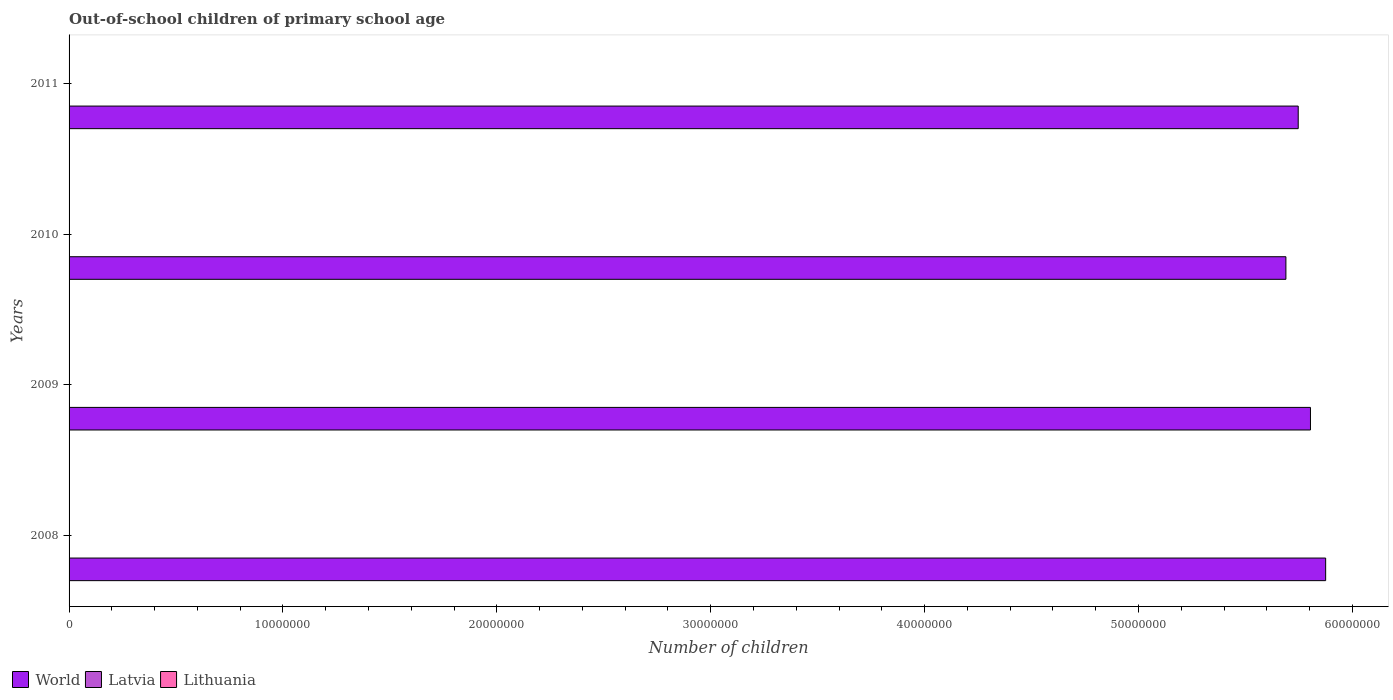Are the number of bars on each tick of the Y-axis equal?
Make the answer very short. Yes. What is the label of the 2nd group of bars from the top?
Your answer should be very brief. 2010. What is the number of out-of-school children in Latvia in 2010?
Give a very brief answer. 2007. Across all years, what is the maximum number of out-of-school children in World?
Keep it short and to the point. 5.88e+07. Across all years, what is the minimum number of out-of-school children in Latvia?
Ensure brevity in your answer.  1985. In which year was the number of out-of-school children in World maximum?
Make the answer very short. 2008. In which year was the number of out-of-school children in World minimum?
Your answer should be compact. 2010. What is the total number of out-of-school children in Lithuania in the graph?
Provide a succinct answer. 6010. What is the difference between the number of out-of-school children in World in 2009 and that in 2010?
Make the answer very short. 1.15e+06. What is the difference between the number of out-of-school children in Lithuania in 2010 and the number of out-of-school children in Latvia in 2009?
Your response must be concise. -682. What is the average number of out-of-school children in World per year?
Provide a short and direct response. 5.78e+07. In the year 2011, what is the difference between the number of out-of-school children in Latvia and number of out-of-school children in Lithuania?
Give a very brief answer. 604. In how many years, is the number of out-of-school children in World greater than 16000000 ?
Keep it short and to the point. 4. What is the ratio of the number of out-of-school children in Lithuania in 2008 to that in 2009?
Your response must be concise. 1.14. Is the difference between the number of out-of-school children in Latvia in 2009 and 2010 greater than the difference between the number of out-of-school children in Lithuania in 2009 and 2010?
Your answer should be compact. No. What is the difference between the highest and the second highest number of out-of-school children in Latvia?
Provide a short and direct response. 1345. What is the difference between the highest and the lowest number of out-of-school children in Latvia?
Provide a succinct answer. 1375. In how many years, is the number of out-of-school children in Latvia greater than the average number of out-of-school children in Latvia taken over all years?
Your answer should be very brief. 1. What does the 1st bar from the top in 2011 represents?
Provide a short and direct response. Lithuania. What does the 1st bar from the bottom in 2009 represents?
Offer a terse response. World. Is it the case that in every year, the sum of the number of out-of-school children in Lithuania and number of out-of-school children in Latvia is greater than the number of out-of-school children in World?
Offer a terse response. No. What is the difference between two consecutive major ticks on the X-axis?
Provide a short and direct response. 1.00e+07. Does the graph contain any zero values?
Provide a short and direct response. No. Does the graph contain grids?
Provide a short and direct response. No. Where does the legend appear in the graph?
Make the answer very short. Bottom left. How many legend labels are there?
Your response must be concise. 3. How are the legend labels stacked?
Make the answer very short. Horizontal. What is the title of the graph?
Your answer should be very brief. Out-of-school children of primary school age. Does "Afghanistan" appear as one of the legend labels in the graph?
Your answer should be very brief. No. What is the label or title of the X-axis?
Offer a very short reply. Number of children. What is the label or title of the Y-axis?
Offer a terse response. Years. What is the Number of children of World in 2008?
Offer a terse response. 5.88e+07. What is the Number of children in Latvia in 2008?
Make the answer very short. 3360. What is the Number of children of Lithuania in 2008?
Give a very brief answer. 1758. What is the Number of children in World in 2009?
Give a very brief answer. 5.80e+07. What is the Number of children in Latvia in 2009?
Give a very brief answer. 2015. What is the Number of children of Lithuania in 2009?
Ensure brevity in your answer.  1538. What is the Number of children in World in 2010?
Ensure brevity in your answer.  5.69e+07. What is the Number of children in Latvia in 2010?
Give a very brief answer. 2007. What is the Number of children of Lithuania in 2010?
Ensure brevity in your answer.  1333. What is the Number of children in World in 2011?
Provide a short and direct response. 5.75e+07. What is the Number of children of Latvia in 2011?
Your response must be concise. 1985. What is the Number of children of Lithuania in 2011?
Provide a short and direct response. 1381. Across all years, what is the maximum Number of children of World?
Your answer should be compact. 5.88e+07. Across all years, what is the maximum Number of children in Latvia?
Offer a terse response. 3360. Across all years, what is the maximum Number of children in Lithuania?
Your answer should be very brief. 1758. Across all years, what is the minimum Number of children of World?
Offer a very short reply. 5.69e+07. Across all years, what is the minimum Number of children of Latvia?
Your answer should be very brief. 1985. Across all years, what is the minimum Number of children in Lithuania?
Your response must be concise. 1333. What is the total Number of children in World in the graph?
Offer a terse response. 2.31e+08. What is the total Number of children of Latvia in the graph?
Ensure brevity in your answer.  9367. What is the total Number of children of Lithuania in the graph?
Make the answer very short. 6010. What is the difference between the Number of children of World in 2008 and that in 2009?
Provide a succinct answer. 7.11e+05. What is the difference between the Number of children in Latvia in 2008 and that in 2009?
Your answer should be compact. 1345. What is the difference between the Number of children of Lithuania in 2008 and that in 2009?
Your answer should be compact. 220. What is the difference between the Number of children in World in 2008 and that in 2010?
Provide a succinct answer. 1.86e+06. What is the difference between the Number of children in Latvia in 2008 and that in 2010?
Offer a terse response. 1353. What is the difference between the Number of children in Lithuania in 2008 and that in 2010?
Provide a succinct answer. 425. What is the difference between the Number of children of World in 2008 and that in 2011?
Your answer should be compact. 1.28e+06. What is the difference between the Number of children of Latvia in 2008 and that in 2011?
Offer a very short reply. 1375. What is the difference between the Number of children of Lithuania in 2008 and that in 2011?
Provide a succinct answer. 377. What is the difference between the Number of children in World in 2009 and that in 2010?
Offer a very short reply. 1.15e+06. What is the difference between the Number of children of Lithuania in 2009 and that in 2010?
Give a very brief answer. 205. What is the difference between the Number of children in World in 2009 and that in 2011?
Make the answer very short. 5.73e+05. What is the difference between the Number of children in Lithuania in 2009 and that in 2011?
Your response must be concise. 157. What is the difference between the Number of children of World in 2010 and that in 2011?
Make the answer very short. -5.76e+05. What is the difference between the Number of children of Lithuania in 2010 and that in 2011?
Offer a terse response. -48. What is the difference between the Number of children of World in 2008 and the Number of children of Latvia in 2009?
Offer a very short reply. 5.88e+07. What is the difference between the Number of children in World in 2008 and the Number of children in Lithuania in 2009?
Offer a very short reply. 5.88e+07. What is the difference between the Number of children in Latvia in 2008 and the Number of children in Lithuania in 2009?
Give a very brief answer. 1822. What is the difference between the Number of children in World in 2008 and the Number of children in Latvia in 2010?
Give a very brief answer. 5.88e+07. What is the difference between the Number of children in World in 2008 and the Number of children in Lithuania in 2010?
Make the answer very short. 5.88e+07. What is the difference between the Number of children of Latvia in 2008 and the Number of children of Lithuania in 2010?
Give a very brief answer. 2027. What is the difference between the Number of children of World in 2008 and the Number of children of Latvia in 2011?
Make the answer very short. 5.88e+07. What is the difference between the Number of children in World in 2008 and the Number of children in Lithuania in 2011?
Offer a very short reply. 5.88e+07. What is the difference between the Number of children in Latvia in 2008 and the Number of children in Lithuania in 2011?
Keep it short and to the point. 1979. What is the difference between the Number of children in World in 2009 and the Number of children in Latvia in 2010?
Give a very brief answer. 5.80e+07. What is the difference between the Number of children in World in 2009 and the Number of children in Lithuania in 2010?
Provide a succinct answer. 5.80e+07. What is the difference between the Number of children of Latvia in 2009 and the Number of children of Lithuania in 2010?
Make the answer very short. 682. What is the difference between the Number of children in World in 2009 and the Number of children in Latvia in 2011?
Provide a short and direct response. 5.80e+07. What is the difference between the Number of children of World in 2009 and the Number of children of Lithuania in 2011?
Offer a very short reply. 5.80e+07. What is the difference between the Number of children of Latvia in 2009 and the Number of children of Lithuania in 2011?
Provide a short and direct response. 634. What is the difference between the Number of children in World in 2010 and the Number of children in Latvia in 2011?
Make the answer very short. 5.69e+07. What is the difference between the Number of children in World in 2010 and the Number of children in Lithuania in 2011?
Your response must be concise. 5.69e+07. What is the difference between the Number of children in Latvia in 2010 and the Number of children in Lithuania in 2011?
Provide a succinct answer. 626. What is the average Number of children in World per year?
Make the answer very short. 5.78e+07. What is the average Number of children of Latvia per year?
Your answer should be compact. 2341.75. What is the average Number of children in Lithuania per year?
Keep it short and to the point. 1502.5. In the year 2008, what is the difference between the Number of children of World and Number of children of Latvia?
Provide a short and direct response. 5.87e+07. In the year 2008, what is the difference between the Number of children in World and Number of children in Lithuania?
Your answer should be compact. 5.88e+07. In the year 2008, what is the difference between the Number of children of Latvia and Number of children of Lithuania?
Make the answer very short. 1602. In the year 2009, what is the difference between the Number of children in World and Number of children in Latvia?
Your response must be concise. 5.80e+07. In the year 2009, what is the difference between the Number of children of World and Number of children of Lithuania?
Keep it short and to the point. 5.80e+07. In the year 2009, what is the difference between the Number of children in Latvia and Number of children in Lithuania?
Keep it short and to the point. 477. In the year 2010, what is the difference between the Number of children of World and Number of children of Latvia?
Provide a succinct answer. 5.69e+07. In the year 2010, what is the difference between the Number of children of World and Number of children of Lithuania?
Keep it short and to the point. 5.69e+07. In the year 2010, what is the difference between the Number of children in Latvia and Number of children in Lithuania?
Your response must be concise. 674. In the year 2011, what is the difference between the Number of children in World and Number of children in Latvia?
Offer a very short reply. 5.75e+07. In the year 2011, what is the difference between the Number of children in World and Number of children in Lithuania?
Ensure brevity in your answer.  5.75e+07. In the year 2011, what is the difference between the Number of children of Latvia and Number of children of Lithuania?
Offer a very short reply. 604. What is the ratio of the Number of children in World in 2008 to that in 2009?
Make the answer very short. 1.01. What is the ratio of the Number of children in Latvia in 2008 to that in 2009?
Your answer should be very brief. 1.67. What is the ratio of the Number of children in Lithuania in 2008 to that in 2009?
Make the answer very short. 1.14. What is the ratio of the Number of children in World in 2008 to that in 2010?
Your response must be concise. 1.03. What is the ratio of the Number of children in Latvia in 2008 to that in 2010?
Provide a short and direct response. 1.67. What is the ratio of the Number of children in Lithuania in 2008 to that in 2010?
Your answer should be very brief. 1.32. What is the ratio of the Number of children in World in 2008 to that in 2011?
Give a very brief answer. 1.02. What is the ratio of the Number of children of Latvia in 2008 to that in 2011?
Ensure brevity in your answer.  1.69. What is the ratio of the Number of children in Lithuania in 2008 to that in 2011?
Offer a terse response. 1.27. What is the ratio of the Number of children of World in 2009 to that in 2010?
Provide a short and direct response. 1.02. What is the ratio of the Number of children in Latvia in 2009 to that in 2010?
Offer a terse response. 1. What is the ratio of the Number of children of Lithuania in 2009 to that in 2010?
Ensure brevity in your answer.  1.15. What is the ratio of the Number of children in World in 2009 to that in 2011?
Make the answer very short. 1.01. What is the ratio of the Number of children of Latvia in 2009 to that in 2011?
Provide a succinct answer. 1.02. What is the ratio of the Number of children of Lithuania in 2009 to that in 2011?
Ensure brevity in your answer.  1.11. What is the ratio of the Number of children in Latvia in 2010 to that in 2011?
Your answer should be compact. 1.01. What is the ratio of the Number of children of Lithuania in 2010 to that in 2011?
Provide a succinct answer. 0.97. What is the difference between the highest and the second highest Number of children in World?
Provide a succinct answer. 7.11e+05. What is the difference between the highest and the second highest Number of children of Latvia?
Give a very brief answer. 1345. What is the difference between the highest and the second highest Number of children in Lithuania?
Your answer should be compact. 220. What is the difference between the highest and the lowest Number of children of World?
Provide a short and direct response. 1.86e+06. What is the difference between the highest and the lowest Number of children in Latvia?
Offer a terse response. 1375. What is the difference between the highest and the lowest Number of children in Lithuania?
Offer a very short reply. 425. 